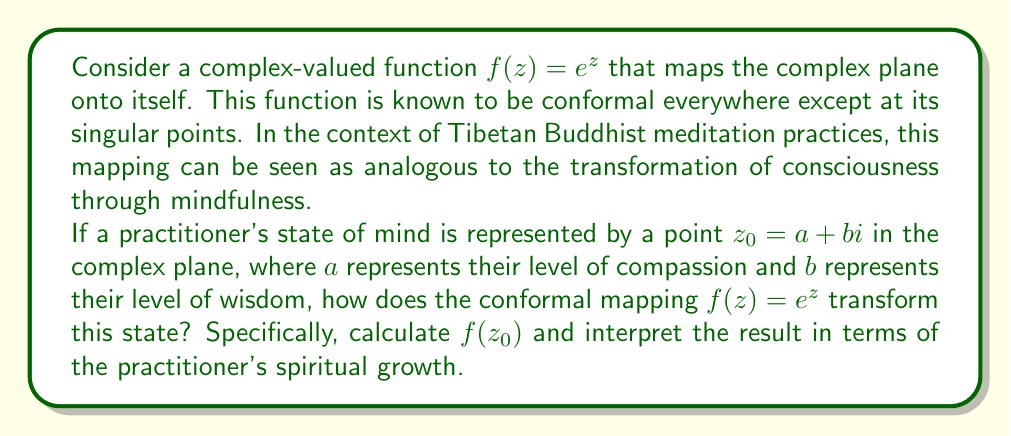Show me your answer to this math problem. To solve this problem, we need to follow these steps:

1) First, let's recall Euler's formula: $e^{x+yi} = e^x(\cos y + i \sin y)$

2) In our case, $z_0 = a + bi$, so we need to calculate $f(z_0) = e^{a+bi}$

3) Applying Euler's formula:

   $f(z_0) = e^{a+bi} = e^a(\cos b + i \sin b)$

4) This can be written in the form $r(\cos \theta + i \sin \theta)$, where:
   
   $r = e^a$
   $\theta = b$

5) Interpreting this result:
   - The magnitude (or modulus) of the transformed point is $e^a$
   - The argument (or angle) of the transformed point is $b$

In the context of Buddhist practice:

- The exponential growth of the magnitude ($e^a$) represents the exponential spiritual growth that can occur through dedicated practice. As compassion (represented by $a$) increases, the overall spiritual state (represented by the magnitude) grows exponentially.

- The preservation of the angle ($b$) in the transformation reflects how wisdom (represented by $b$) maintains its proportion relative to compassion in the practitioner's spiritual state, even as both grow.

- The conformal nature of this mapping (angle-preserving) could be interpreted as maintaining the balance between compassion and wisdom, which is crucial in Buddhist practice.

This transformation illustrates how focused spiritual practice can lead to profound growth while maintaining the essential balance of qualities that constitute enlightened consciousness.
Answer: $f(z_0) = e^a(\cos b + i \sin b)$, where $e^a$ represents the exponential growth in the practitioner's overall spiritual state, and $b$ represents the maintained balance between compassion and wisdom. 